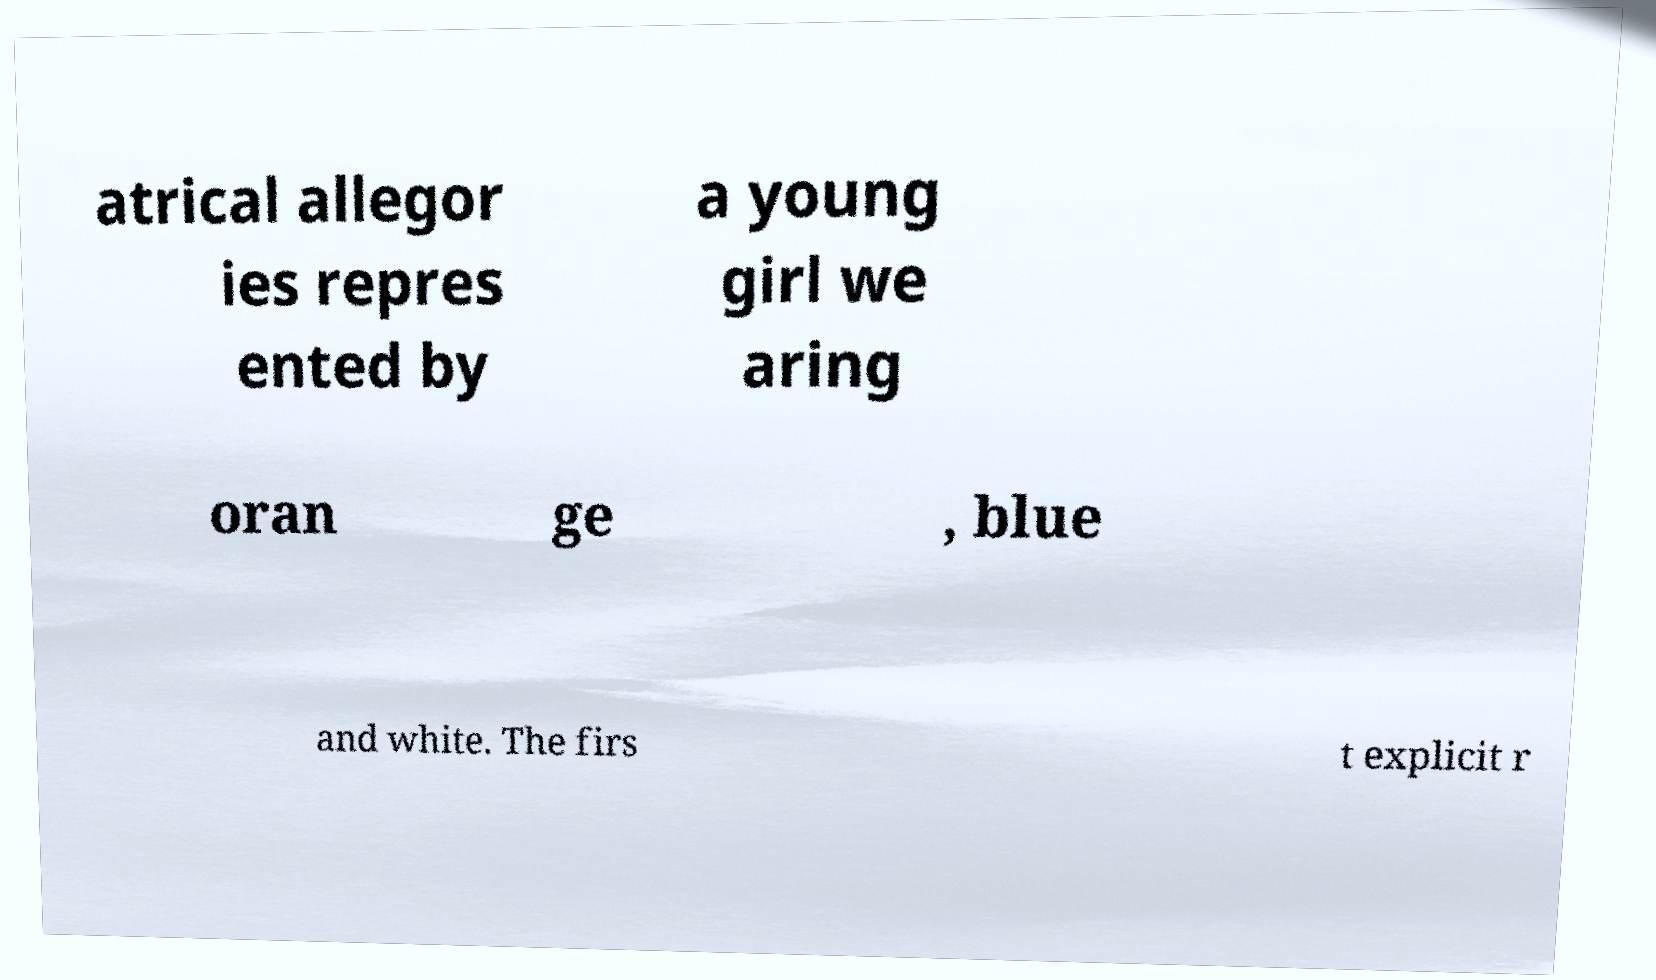Please identify and transcribe the text found in this image. atrical allegor ies repres ented by a young girl we aring oran ge , blue and white. The firs t explicit r 